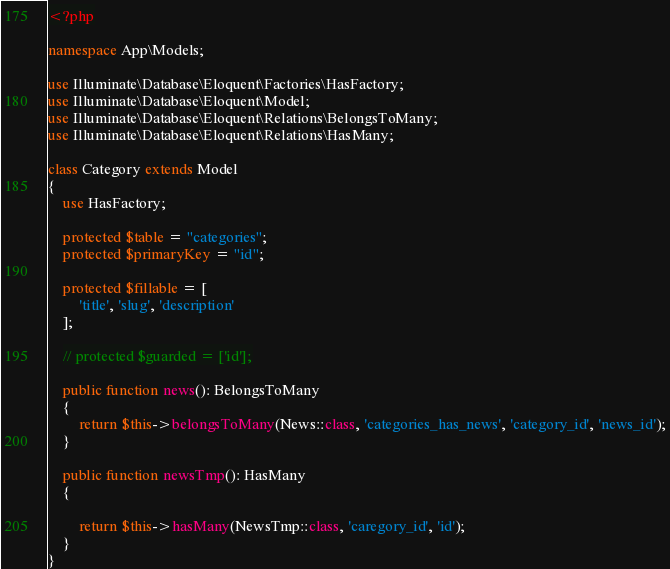Convert code to text. <code><loc_0><loc_0><loc_500><loc_500><_PHP_><?php

namespace App\Models;

use Illuminate\Database\Eloquent\Factories\HasFactory;
use Illuminate\Database\Eloquent\Model;
use Illuminate\Database\Eloquent\Relations\BelongsToMany;
use Illuminate\Database\Eloquent\Relations\HasMany;

class Category extends Model
{
    use HasFactory;

    protected $table = "categories";
    protected $primaryKey = "id";

    protected $fillable = [
        'title', 'slug', 'description'
    ];

    // protected $guarded = ['id'];

    public function news(): BelongsToMany
    {
        return $this->belongsToMany(News::class, 'categories_has_news', 'category_id', 'news_id');
    }

    public function newsTmp(): HasMany
    {

        return $this->hasMany(NewsTmp::class, 'caregory_id', 'id');
    }
}
</code> 